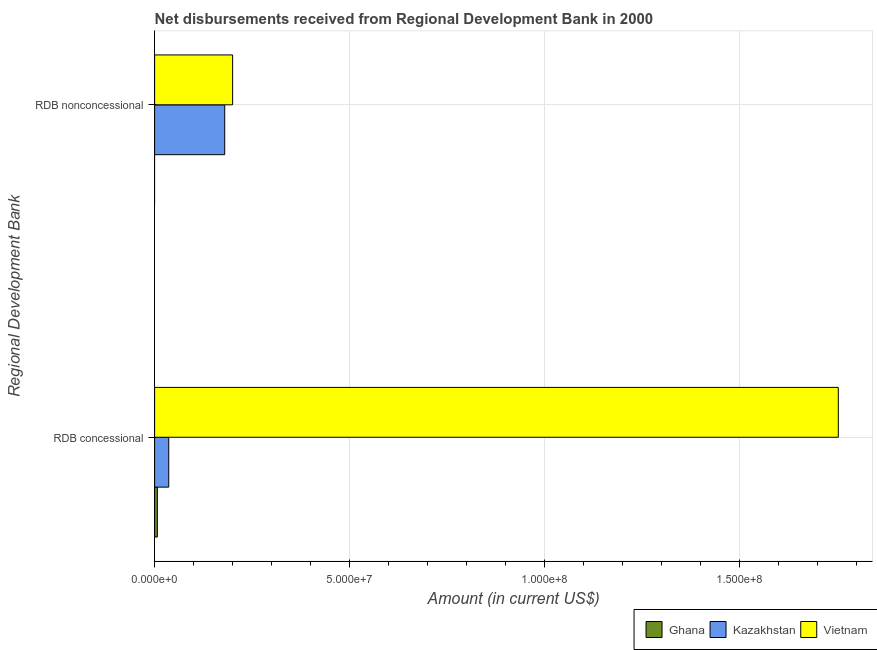How many different coloured bars are there?
Provide a short and direct response. 3. How many bars are there on the 1st tick from the top?
Ensure brevity in your answer.  2. How many bars are there on the 2nd tick from the bottom?
Keep it short and to the point. 2. What is the label of the 2nd group of bars from the top?
Your answer should be very brief. RDB concessional. What is the net non concessional disbursements from rdb in Vietnam?
Keep it short and to the point. 2.00e+07. Across all countries, what is the maximum net non concessional disbursements from rdb?
Provide a short and direct response. 2.00e+07. Across all countries, what is the minimum net non concessional disbursements from rdb?
Your answer should be very brief. 0. In which country was the net non concessional disbursements from rdb maximum?
Your response must be concise. Vietnam. What is the total net concessional disbursements from rdb in the graph?
Make the answer very short. 1.80e+08. What is the difference between the net concessional disbursements from rdb in Kazakhstan and that in Ghana?
Provide a short and direct response. 2.92e+06. What is the difference between the net non concessional disbursements from rdb in Kazakhstan and the net concessional disbursements from rdb in Ghana?
Your response must be concise. 1.73e+07. What is the average net non concessional disbursements from rdb per country?
Give a very brief answer. 1.27e+07. What is the difference between the net concessional disbursements from rdb and net non concessional disbursements from rdb in Vietnam?
Your answer should be very brief. 1.55e+08. What is the ratio of the net concessional disbursements from rdb in Vietnam to that in Ghana?
Make the answer very short. 248.25. Is the net non concessional disbursements from rdb in Vietnam less than that in Kazakhstan?
Ensure brevity in your answer.  No. Are all the bars in the graph horizontal?
Provide a short and direct response. Yes. How many countries are there in the graph?
Offer a very short reply. 3. What is the difference between two consecutive major ticks on the X-axis?
Offer a terse response. 5.00e+07. Does the graph contain any zero values?
Offer a very short reply. Yes. Does the graph contain grids?
Make the answer very short. Yes. How many legend labels are there?
Your response must be concise. 3. What is the title of the graph?
Give a very brief answer. Net disbursements received from Regional Development Bank in 2000. Does "Madagascar" appear as one of the legend labels in the graph?
Ensure brevity in your answer.  No. What is the label or title of the X-axis?
Ensure brevity in your answer.  Amount (in current US$). What is the label or title of the Y-axis?
Ensure brevity in your answer.  Regional Development Bank. What is the Amount (in current US$) in Ghana in RDB concessional?
Make the answer very short. 7.06e+05. What is the Amount (in current US$) in Kazakhstan in RDB concessional?
Provide a short and direct response. 3.62e+06. What is the Amount (in current US$) of Vietnam in RDB concessional?
Offer a very short reply. 1.75e+08. What is the Amount (in current US$) of Ghana in RDB nonconcessional?
Give a very brief answer. 0. What is the Amount (in current US$) in Kazakhstan in RDB nonconcessional?
Offer a very short reply. 1.80e+07. What is the Amount (in current US$) of Vietnam in RDB nonconcessional?
Your answer should be compact. 2.00e+07. Across all Regional Development Bank, what is the maximum Amount (in current US$) in Ghana?
Give a very brief answer. 7.06e+05. Across all Regional Development Bank, what is the maximum Amount (in current US$) in Kazakhstan?
Offer a terse response. 1.80e+07. Across all Regional Development Bank, what is the maximum Amount (in current US$) in Vietnam?
Make the answer very short. 1.75e+08. Across all Regional Development Bank, what is the minimum Amount (in current US$) in Kazakhstan?
Give a very brief answer. 3.62e+06. Across all Regional Development Bank, what is the minimum Amount (in current US$) in Vietnam?
Your response must be concise. 2.00e+07. What is the total Amount (in current US$) in Ghana in the graph?
Offer a very short reply. 7.06e+05. What is the total Amount (in current US$) of Kazakhstan in the graph?
Offer a very short reply. 2.16e+07. What is the total Amount (in current US$) in Vietnam in the graph?
Provide a succinct answer. 1.95e+08. What is the difference between the Amount (in current US$) in Kazakhstan in RDB concessional and that in RDB nonconcessional?
Offer a terse response. -1.44e+07. What is the difference between the Amount (in current US$) of Vietnam in RDB concessional and that in RDB nonconcessional?
Keep it short and to the point. 1.55e+08. What is the difference between the Amount (in current US$) of Ghana in RDB concessional and the Amount (in current US$) of Kazakhstan in RDB nonconcessional?
Your answer should be very brief. -1.73e+07. What is the difference between the Amount (in current US$) of Ghana in RDB concessional and the Amount (in current US$) of Vietnam in RDB nonconcessional?
Give a very brief answer. -1.93e+07. What is the difference between the Amount (in current US$) in Kazakhstan in RDB concessional and the Amount (in current US$) in Vietnam in RDB nonconcessional?
Make the answer very short. -1.64e+07. What is the average Amount (in current US$) in Ghana per Regional Development Bank?
Your answer should be very brief. 3.53e+05. What is the average Amount (in current US$) of Kazakhstan per Regional Development Bank?
Provide a short and direct response. 1.08e+07. What is the average Amount (in current US$) in Vietnam per Regional Development Bank?
Your answer should be very brief. 9.76e+07. What is the difference between the Amount (in current US$) in Ghana and Amount (in current US$) in Kazakhstan in RDB concessional?
Offer a terse response. -2.92e+06. What is the difference between the Amount (in current US$) of Ghana and Amount (in current US$) of Vietnam in RDB concessional?
Provide a succinct answer. -1.75e+08. What is the difference between the Amount (in current US$) of Kazakhstan and Amount (in current US$) of Vietnam in RDB concessional?
Offer a terse response. -1.72e+08. What is the difference between the Amount (in current US$) in Kazakhstan and Amount (in current US$) in Vietnam in RDB nonconcessional?
Provide a short and direct response. -2.02e+06. What is the ratio of the Amount (in current US$) of Kazakhstan in RDB concessional to that in RDB nonconcessional?
Keep it short and to the point. 0.2. What is the ratio of the Amount (in current US$) of Vietnam in RDB concessional to that in RDB nonconcessional?
Give a very brief answer. 8.76. What is the difference between the highest and the second highest Amount (in current US$) in Kazakhstan?
Your answer should be very brief. 1.44e+07. What is the difference between the highest and the second highest Amount (in current US$) in Vietnam?
Your answer should be compact. 1.55e+08. What is the difference between the highest and the lowest Amount (in current US$) in Ghana?
Make the answer very short. 7.06e+05. What is the difference between the highest and the lowest Amount (in current US$) in Kazakhstan?
Your answer should be compact. 1.44e+07. What is the difference between the highest and the lowest Amount (in current US$) in Vietnam?
Make the answer very short. 1.55e+08. 